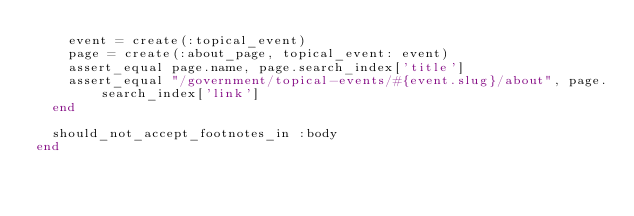Convert code to text. <code><loc_0><loc_0><loc_500><loc_500><_Ruby_>    event = create(:topical_event)
    page = create(:about_page, topical_event: event)
    assert_equal page.name, page.search_index['title']
    assert_equal "/government/topical-events/#{event.slug}/about", page.search_index['link']
  end

  should_not_accept_footnotes_in :body
end
</code> 